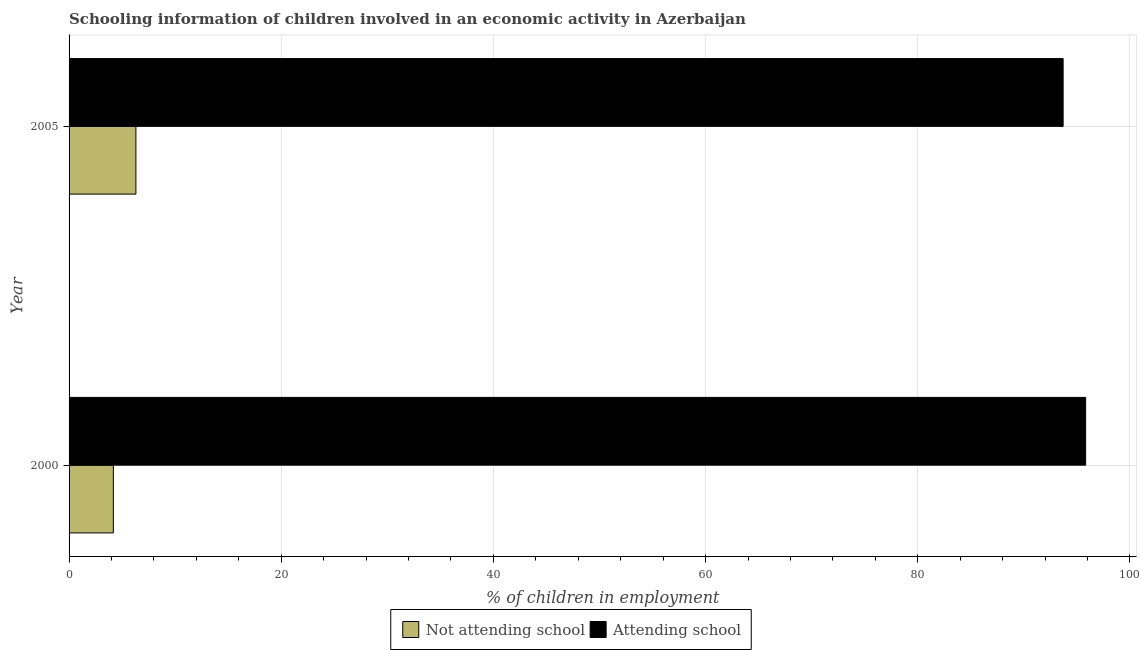Are the number of bars per tick equal to the number of legend labels?
Make the answer very short. Yes. What is the percentage of employed children who are not attending school in 2000?
Your answer should be compact. 4.18. Across all years, what is the maximum percentage of employed children who are attending school?
Your answer should be very brief. 95.82. Across all years, what is the minimum percentage of employed children who are attending school?
Make the answer very short. 93.7. What is the total percentage of employed children who are attending school in the graph?
Ensure brevity in your answer.  189.52. What is the difference between the percentage of employed children who are attending school in 2000 and that in 2005?
Offer a very short reply. 2.12. What is the difference between the percentage of employed children who are attending school in 2000 and the percentage of employed children who are not attending school in 2005?
Offer a very short reply. 89.52. What is the average percentage of employed children who are not attending school per year?
Your answer should be very brief. 5.24. In the year 2005, what is the difference between the percentage of employed children who are not attending school and percentage of employed children who are attending school?
Provide a succinct answer. -87.4. In how many years, is the percentage of employed children who are attending school greater than 20 %?
Give a very brief answer. 2. Is the difference between the percentage of employed children who are not attending school in 2000 and 2005 greater than the difference between the percentage of employed children who are attending school in 2000 and 2005?
Your response must be concise. No. In how many years, is the percentage of employed children who are attending school greater than the average percentage of employed children who are attending school taken over all years?
Make the answer very short. 1. What does the 1st bar from the top in 2000 represents?
Keep it short and to the point. Attending school. What does the 2nd bar from the bottom in 2005 represents?
Your answer should be very brief. Attending school. Are all the bars in the graph horizontal?
Your response must be concise. Yes. How many years are there in the graph?
Provide a succinct answer. 2. Are the values on the major ticks of X-axis written in scientific E-notation?
Provide a short and direct response. No. Does the graph contain grids?
Keep it short and to the point. Yes. Where does the legend appear in the graph?
Offer a very short reply. Bottom center. How many legend labels are there?
Your answer should be compact. 2. How are the legend labels stacked?
Provide a succinct answer. Horizontal. What is the title of the graph?
Offer a terse response. Schooling information of children involved in an economic activity in Azerbaijan. What is the label or title of the X-axis?
Provide a short and direct response. % of children in employment. What is the % of children in employment of Not attending school in 2000?
Your answer should be very brief. 4.18. What is the % of children in employment in Attending school in 2000?
Provide a short and direct response. 95.82. What is the % of children in employment in Attending school in 2005?
Provide a short and direct response. 93.7. Across all years, what is the maximum % of children in employment of Attending school?
Give a very brief answer. 95.82. Across all years, what is the minimum % of children in employment of Not attending school?
Make the answer very short. 4.18. Across all years, what is the minimum % of children in employment in Attending school?
Your answer should be compact. 93.7. What is the total % of children in employment of Not attending school in the graph?
Make the answer very short. 10.48. What is the total % of children in employment of Attending school in the graph?
Offer a very short reply. 189.52. What is the difference between the % of children in employment in Not attending school in 2000 and that in 2005?
Keep it short and to the point. -2.12. What is the difference between the % of children in employment of Attending school in 2000 and that in 2005?
Keep it short and to the point. 2.12. What is the difference between the % of children in employment in Not attending school in 2000 and the % of children in employment in Attending school in 2005?
Give a very brief answer. -89.52. What is the average % of children in employment in Not attending school per year?
Provide a succinct answer. 5.24. What is the average % of children in employment in Attending school per year?
Give a very brief answer. 94.76. In the year 2000, what is the difference between the % of children in employment in Not attending school and % of children in employment in Attending school?
Offer a terse response. -91.65. In the year 2005, what is the difference between the % of children in employment of Not attending school and % of children in employment of Attending school?
Give a very brief answer. -87.4. What is the ratio of the % of children in employment in Not attending school in 2000 to that in 2005?
Your response must be concise. 0.66. What is the ratio of the % of children in employment of Attending school in 2000 to that in 2005?
Your response must be concise. 1.02. What is the difference between the highest and the second highest % of children in employment in Not attending school?
Make the answer very short. 2.12. What is the difference between the highest and the second highest % of children in employment of Attending school?
Your answer should be very brief. 2.12. What is the difference between the highest and the lowest % of children in employment in Not attending school?
Your answer should be very brief. 2.12. What is the difference between the highest and the lowest % of children in employment of Attending school?
Keep it short and to the point. 2.12. 